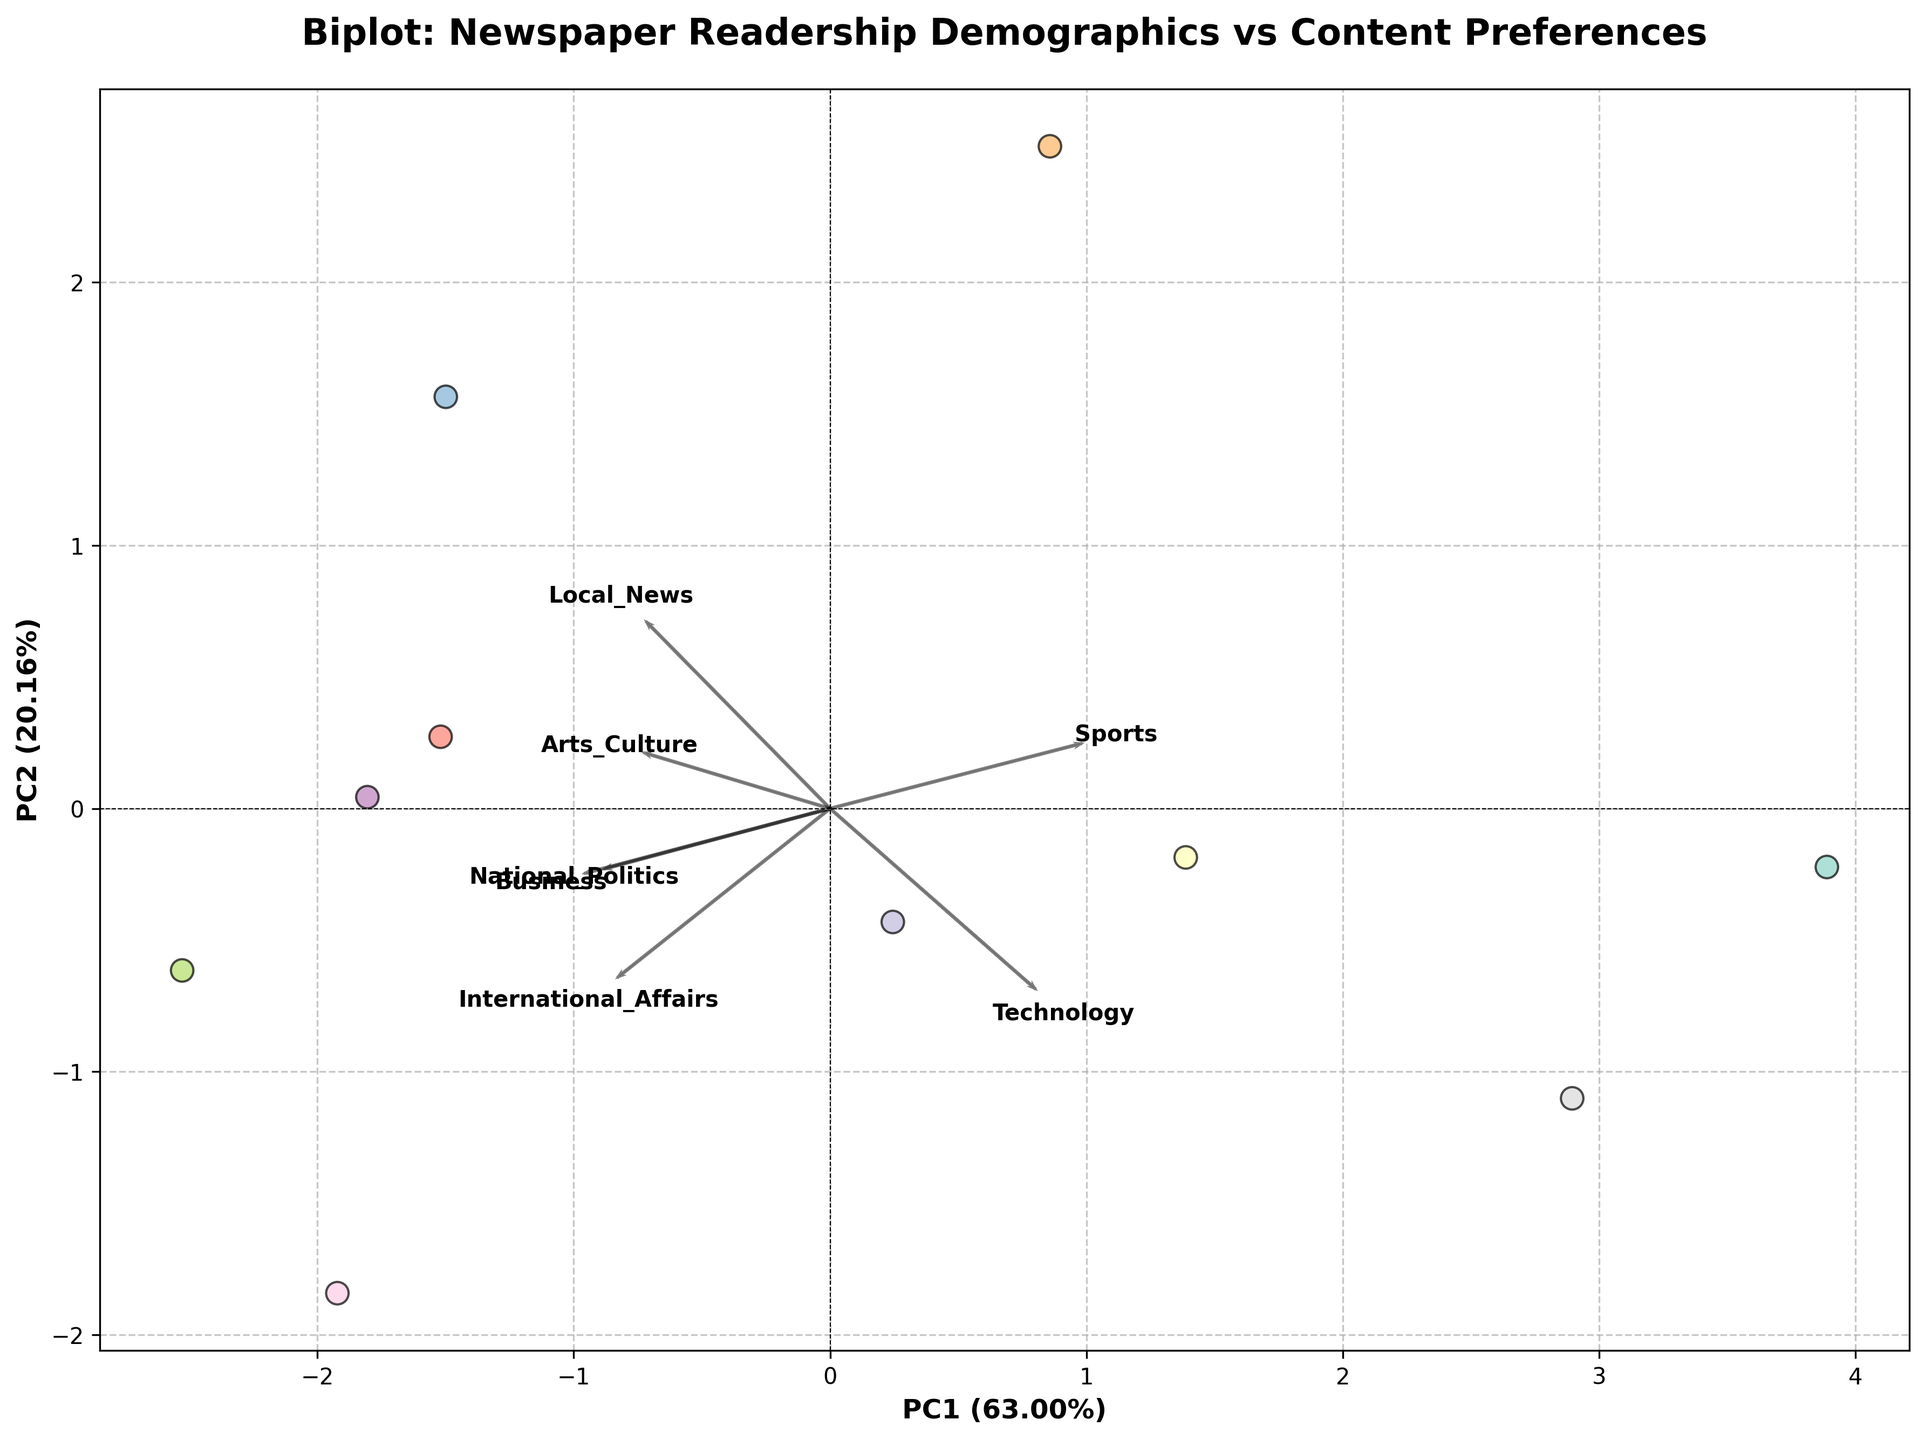Which age group has the highest representation in the dataset? By observing the legend and its entries, we can determine which age group appears the most frequently in the scatter plot. The "65+" age group is represented by two different education levels, so it appears twice.
Answer: 65+ Which two content preferences have the highest loading on the first principal component (PC1)? Loadings are depicted by arrows on the plot. The length and direction of the arrows help determine which content preferences have the highest loadings. The arrows for 'Local_News' and 'International_Affairs' appear to have the highest loading on PC1.
Answer: Local_News and International_Affairs How much variance is explained by the first principal component (PC1)? The explained variance for PC1 is represented on the x-axis label as a percentage. By looking at the x-axis label, we can find the exact percentage.
Answer: Approximately 41% What educational level is more likely to prefer technology-related content? By assessing the scatter points and their colors relative to the 'Technology' arrow direction, we can deduce which educational level is more closely aligned. Scatter points for younger age groups (18-24) who are marked as having 'High School' or 'Master's' education levels are closer to the Technology arrow.
Answer: High School and Master's Which component (PC1 or PC2) has a stronger influence on the 'Sports' content preference? The 'Sports' arrow's direction and the relative length of its projection onto the PC1 and PC2 axes will indicate its influence strengths. From the arrow's projection, 'Sports' has a stronger influence along PC1.
Answer: PC1 Based on the biplot, which age group appears closer to 'Arts_Culture' preference? We look at the proximity of age group scatter points to the 'Arts_Culture' arrow direction and length. The age groups '55-64' and '65+' appear closer to the 'Arts_Culture' arrow.
Answer: 55-64 and 65+ Compare the preferences between the '35-44; PhD' group and the '18-24; Master's' group. Which content preference exhibits the largest difference? By comparing the positions of these two points individually with respect to each content preference arrow, we can determine which content has the largest difference. The 'Technology' content preference exhibits the largest divergence in terms of preference.
Answer: Technology Which age group has the least interest in 'Business' news? By observing scatter points along the 'Business' arrow and identifying which age group is farthest from it, we can infer the least interest. The '18-24' age group (with higher education levels) appears the least interested in Business news.
Answer: 18-24 How does the interest in 'National_Politics' change with education level in the '65+' age group? We analyze scatter points belonging to the '65+' age group with different education levels and observe their alignment with the 'National_Politics' arrow. The point representing 'PhD' has a higher alignment with the National_Politics arrow.
Answer: It increases with education level Which content preferences are closely related to each other according to the biplot? By examining the angles between the arrows of various content preferences, we can determine which are closely related. Smaller angles suggest higher correlations. 'Local_News' and 'Business', as well as 'Arts_Culture' and 'Sports', have smaller angles between their arrows.
Answer: Local_News and Business, Arts_Culture and Sports 